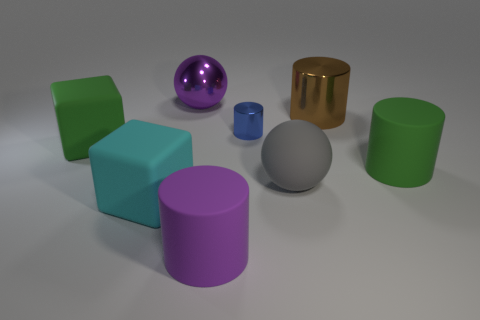There is a cylinder to the left of the blue thing; is it the same color as the sphere that is behind the big gray matte object?
Offer a terse response. Yes. What material is the other green object that is the same shape as the tiny thing?
Offer a very short reply. Rubber. What size is the cylinder that is the same color as the large metallic sphere?
Your answer should be very brief. Large. How many big cylinders have the same color as the big shiny ball?
Your response must be concise. 1. What color is the metal sphere that is the same size as the brown cylinder?
Your response must be concise. Purple. Are the object on the left side of the cyan rubber cube and the tiny cylinder made of the same material?
Your response must be concise. No. There is a object that is right of the blue metal cylinder and behind the small blue thing; what size is it?
Keep it short and to the point. Large. How big is the metallic object on the right side of the large gray rubber sphere?
Your answer should be compact. Large. The matte thing that is the same color as the big shiny ball is what shape?
Ensure brevity in your answer.  Cylinder. There is a green matte thing left of the cube that is to the right of the large rubber block that is behind the cyan matte thing; what is its shape?
Your answer should be very brief. Cube. 